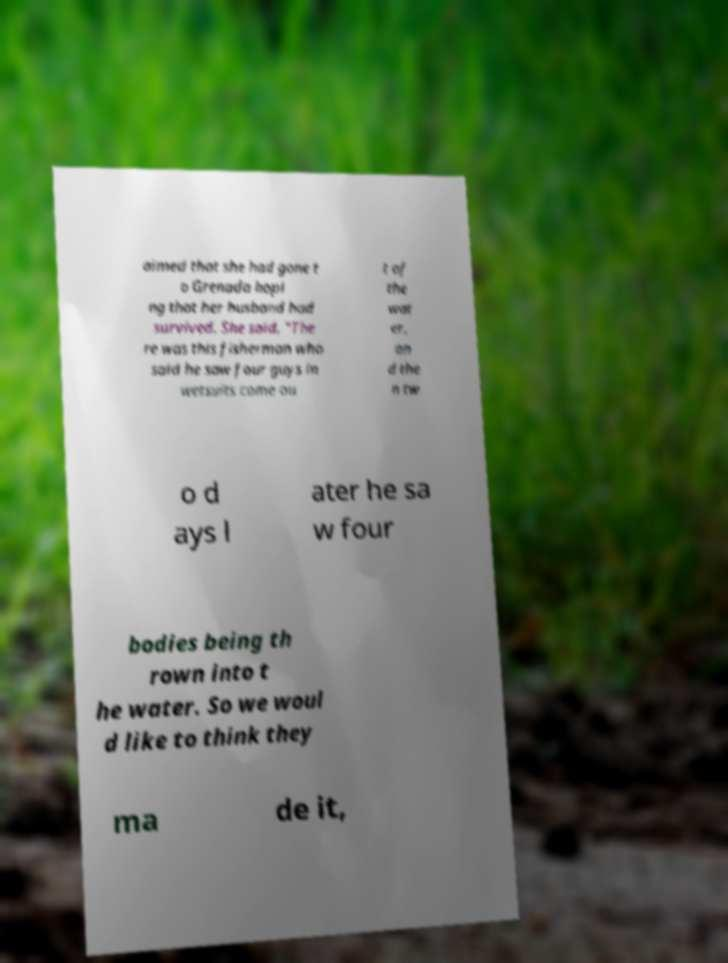Can you accurately transcribe the text from the provided image for me? aimed that she had gone t o Grenada hopi ng that her husband had survived. She said, "The re was this fisherman who said he saw four guys in wetsuits come ou t of the wat er, an d the n tw o d ays l ater he sa w four bodies being th rown into t he water. So we woul d like to think they ma de it, 